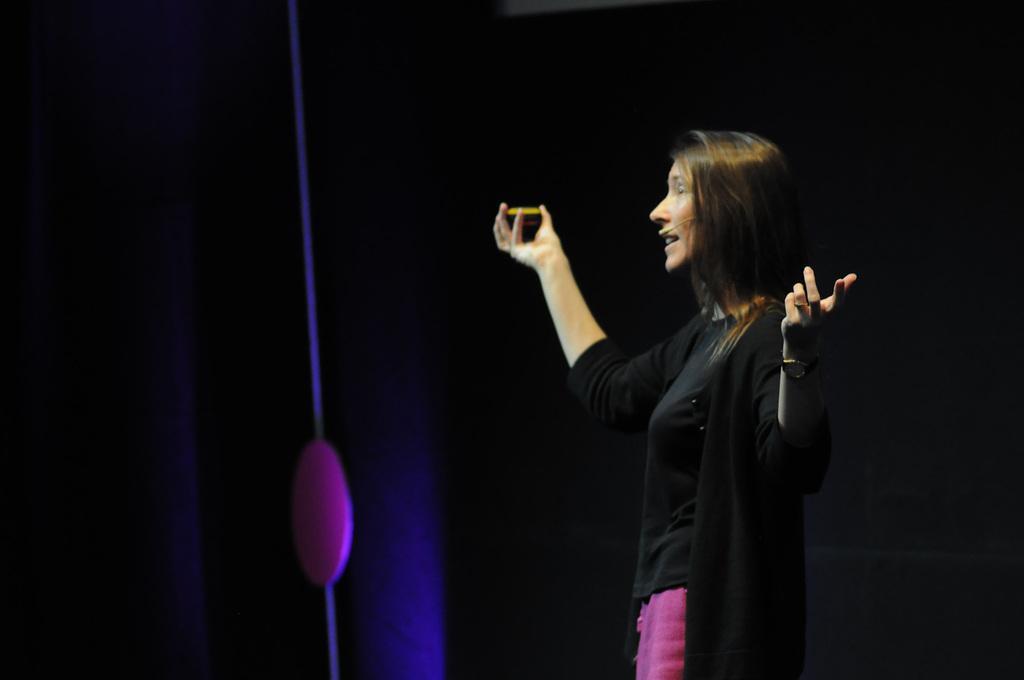Please provide a concise description of this image. In this picture I can see a woman standing and hand holding something in one hand and speaking with the help of a microphone. 